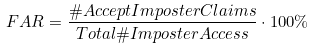<formula> <loc_0><loc_0><loc_500><loc_500>F A R = \frac { \# A c c e p t I m p o s t e r C l a i m s } { T o t a l \# I m p o s t e r A c c e s s } \cdot 1 0 0 \%</formula> 